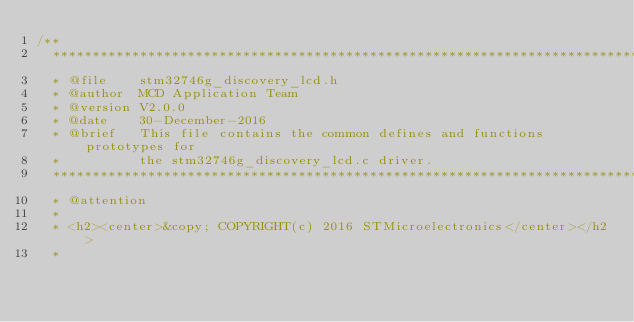<code> <loc_0><loc_0><loc_500><loc_500><_C_>/**
  ******************************************************************************
  * @file    stm32746g_discovery_lcd.h
  * @author  MCD Application Team
  * @version V2.0.0
  * @date    30-December-2016
  * @brief   This file contains the common defines and functions prototypes for
  *          the stm32746g_discovery_lcd.c driver.
  ******************************************************************************
  * @attention
  *
  * <h2><center>&copy; COPYRIGHT(c) 2016 STMicroelectronics</center></h2>
  *</code> 